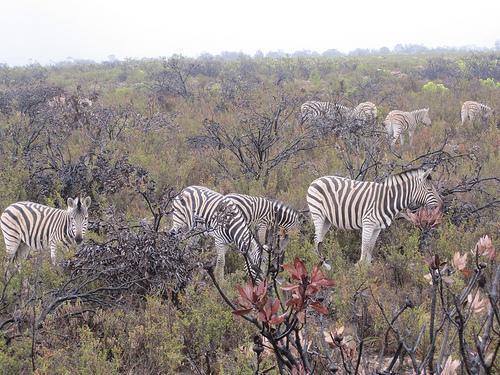How many zebras are there?
Give a very brief answer. 8. 